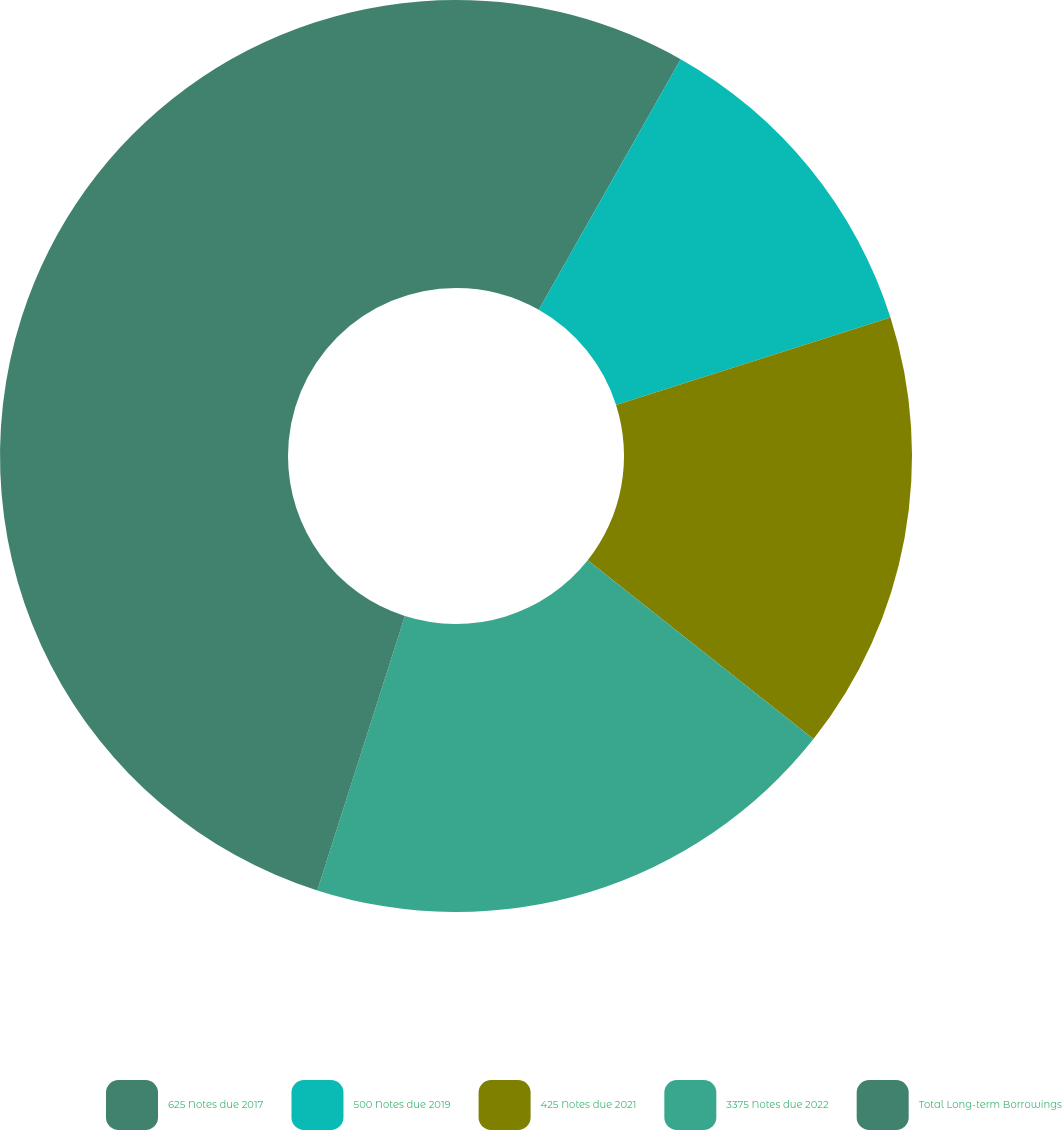Convert chart. <chart><loc_0><loc_0><loc_500><loc_500><pie_chart><fcel>625 Notes due 2017<fcel>500 Notes due 2019<fcel>425 Notes due 2021<fcel>3375 Notes due 2022<fcel>Total Long-term Borrowings<nl><fcel>8.2%<fcel>11.89%<fcel>15.57%<fcel>19.26%<fcel>45.08%<nl></chart> 